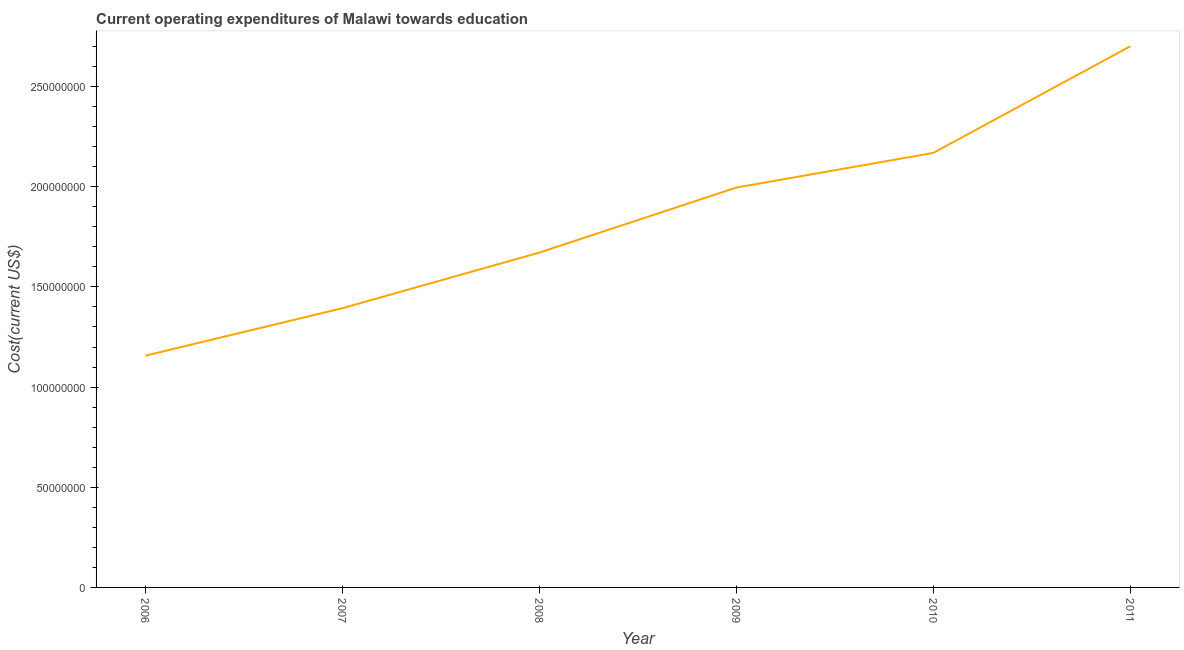What is the education expenditure in 2008?
Make the answer very short. 1.67e+08. Across all years, what is the maximum education expenditure?
Ensure brevity in your answer.  2.70e+08. Across all years, what is the minimum education expenditure?
Give a very brief answer. 1.16e+08. What is the sum of the education expenditure?
Give a very brief answer. 1.11e+09. What is the difference between the education expenditure in 2007 and 2011?
Give a very brief answer. -1.31e+08. What is the average education expenditure per year?
Offer a terse response. 1.85e+08. What is the median education expenditure?
Make the answer very short. 1.83e+08. In how many years, is the education expenditure greater than 180000000 US$?
Your response must be concise. 3. Do a majority of the years between 2011 and 2007 (inclusive) have education expenditure greater than 130000000 US$?
Provide a succinct answer. Yes. What is the ratio of the education expenditure in 2008 to that in 2010?
Offer a terse response. 0.77. Is the education expenditure in 2007 less than that in 2009?
Offer a very short reply. Yes. Is the difference between the education expenditure in 2007 and 2010 greater than the difference between any two years?
Provide a succinct answer. No. What is the difference between the highest and the second highest education expenditure?
Provide a short and direct response. 5.32e+07. What is the difference between the highest and the lowest education expenditure?
Give a very brief answer. 1.54e+08. In how many years, is the education expenditure greater than the average education expenditure taken over all years?
Ensure brevity in your answer.  3. Does the education expenditure monotonically increase over the years?
Offer a terse response. Yes. How many years are there in the graph?
Offer a very short reply. 6. Are the values on the major ticks of Y-axis written in scientific E-notation?
Provide a short and direct response. No. Does the graph contain any zero values?
Your answer should be compact. No. Does the graph contain grids?
Provide a succinct answer. No. What is the title of the graph?
Make the answer very short. Current operating expenditures of Malawi towards education. What is the label or title of the X-axis?
Keep it short and to the point. Year. What is the label or title of the Y-axis?
Give a very brief answer. Cost(current US$). What is the Cost(current US$) of 2006?
Your answer should be very brief. 1.16e+08. What is the Cost(current US$) in 2007?
Give a very brief answer. 1.39e+08. What is the Cost(current US$) in 2008?
Provide a short and direct response. 1.67e+08. What is the Cost(current US$) in 2009?
Keep it short and to the point. 2.00e+08. What is the Cost(current US$) in 2010?
Your answer should be compact. 2.17e+08. What is the Cost(current US$) in 2011?
Offer a terse response. 2.70e+08. What is the difference between the Cost(current US$) in 2006 and 2007?
Your answer should be very brief. -2.37e+07. What is the difference between the Cost(current US$) in 2006 and 2008?
Your answer should be very brief. -5.15e+07. What is the difference between the Cost(current US$) in 2006 and 2009?
Ensure brevity in your answer.  -8.39e+07. What is the difference between the Cost(current US$) in 2006 and 2010?
Make the answer very short. -1.01e+08. What is the difference between the Cost(current US$) in 2006 and 2011?
Make the answer very short. -1.54e+08. What is the difference between the Cost(current US$) in 2007 and 2008?
Keep it short and to the point. -2.78e+07. What is the difference between the Cost(current US$) in 2007 and 2009?
Ensure brevity in your answer.  -6.02e+07. What is the difference between the Cost(current US$) in 2007 and 2010?
Provide a short and direct response. -7.75e+07. What is the difference between the Cost(current US$) in 2007 and 2011?
Make the answer very short. -1.31e+08. What is the difference between the Cost(current US$) in 2008 and 2009?
Your response must be concise. -3.24e+07. What is the difference between the Cost(current US$) in 2008 and 2010?
Offer a terse response. -4.98e+07. What is the difference between the Cost(current US$) in 2008 and 2011?
Make the answer very short. -1.03e+08. What is the difference between the Cost(current US$) in 2009 and 2010?
Ensure brevity in your answer.  -1.73e+07. What is the difference between the Cost(current US$) in 2009 and 2011?
Keep it short and to the point. -7.05e+07. What is the difference between the Cost(current US$) in 2010 and 2011?
Offer a very short reply. -5.32e+07. What is the ratio of the Cost(current US$) in 2006 to that in 2007?
Your answer should be compact. 0.83. What is the ratio of the Cost(current US$) in 2006 to that in 2008?
Ensure brevity in your answer.  0.69. What is the ratio of the Cost(current US$) in 2006 to that in 2009?
Your answer should be compact. 0.58. What is the ratio of the Cost(current US$) in 2006 to that in 2010?
Make the answer very short. 0.53. What is the ratio of the Cost(current US$) in 2006 to that in 2011?
Offer a very short reply. 0.43. What is the ratio of the Cost(current US$) in 2007 to that in 2008?
Offer a terse response. 0.83. What is the ratio of the Cost(current US$) in 2007 to that in 2009?
Provide a short and direct response. 0.7. What is the ratio of the Cost(current US$) in 2007 to that in 2010?
Give a very brief answer. 0.64. What is the ratio of the Cost(current US$) in 2007 to that in 2011?
Provide a short and direct response. 0.52. What is the ratio of the Cost(current US$) in 2008 to that in 2009?
Keep it short and to the point. 0.84. What is the ratio of the Cost(current US$) in 2008 to that in 2010?
Provide a succinct answer. 0.77. What is the ratio of the Cost(current US$) in 2008 to that in 2011?
Offer a terse response. 0.62. What is the ratio of the Cost(current US$) in 2009 to that in 2010?
Your answer should be compact. 0.92. What is the ratio of the Cost(current US$) in 2009 to that in 2011?
Give a very brief answer. 0.74. What is the ratio of the Cost(current US$) in 2010 to that in 2011?
Provide a short and direct response. 0.8. 